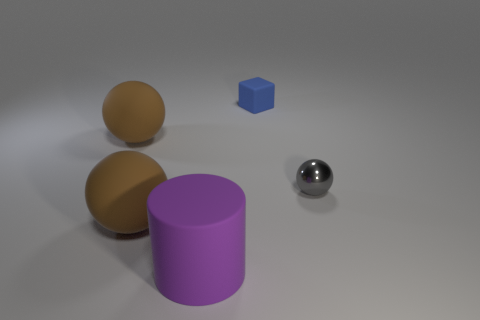Is there any other thing that is the same shape as the tiny rubber object?
Your answer should be compact. No. There is a big rubber thing that is behind the object on the right side of the tiny blue thing; what shape is it?
Provide a succinct answer. Sphere. Do the ball that is right of the large rubber cylinder and the brown ball that is behind the small sphere have the same material?
Offer a terse response. No. What number of large purple rubber objects are in front of the sphere right of the rubber block?
Offer a very short reply. 1. There is a small object that is in front of the tiny blue matte object; is it the same shape as the large brown matte object that is in front of the small gray metallic thing?
Offer a very short reply. Yes. How big is the object that is on the right side of the big purple matte object and in front of the blue rubber cube?
Offer a very short reply. Small. The large matte ball that is behind the ball that is to the right of the big matte cylinder is what color?
Ensure brevity in your answer.  Brown. The gray metallic object is what shape?
Offer a terse response. Sphere. There is a thing that is both in front of the small cube and on the right side of the rubber cylinder; what is its shape?
Make the answer very short. Sphere. The big cylinder that is made of the same material as the tiny blue object is what color?
Provide a succinct answer. Purple. 